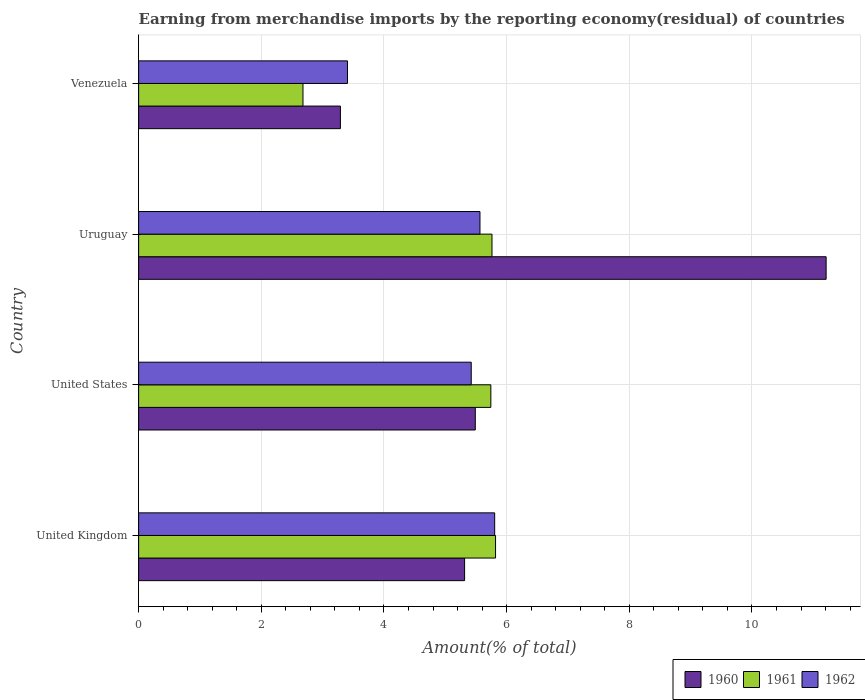How many different coloured bars are there?
Provide a succinct answer. 3. How many groups of bars are there?
Your answer should be compact. 4. Are the number of bars per tick equal to the number of legend labels?
Your response must be concise. Yes. How many bars are there on the 3rd tick from the bottom?
Provide a succinct answer. 3. What is the label of the 3rd group of bars from the top?
Provide a succinct answer. United States. What is the percentage of amount earned from merchandise imports in 1960 in Uruguay?
Make the answer very short. 11.21. Across all countries, what is the maximum percentage of amount earned from merchandise imports in 1962?
Give a very brief answer. 5.8. Across all countries, what is the minimum percentage of amount earned from merchandise imports in 1960?
Your answer should be compact. 3.29. In which country was the percentage of amount earned from merchandise imports in 1960 minimum?
Your answer should be compact. Venezuela. What is the total percentage of amount earned from merchandise imports in 1962 in the graph?
Your response must be concise. 20.2. What is the difference between the percentage of amount earned from merchandise imports in 1962 in United States and that in Uruguay?
Make the answer very short. -0.14. What is the difference between the percentage of amount earned from merchandise imports in 1961 in Venezuela and the percentage of amount earned from merchandise imports in 1960 in Uruguay?
Your answer should be very brief. -8.53. What is the average percentage of amount earned from merchandise imports in 1960 per country?
Make the answer very short. 6.33. What is the difference between the percentage of amount earned from merchandise imports in 1960 and percentage of amount earned from merchandise imports in 1961 in Uruguay?
Ensure brevity in your answer.  5.45. What is the ratio of the percentage of amount earned from merchandise imports in 1960 in United States to that in Venezuela?
Your response must be concise. 1.67. Is the difference between the percentage of amount earned from merchandise imports in 1960 in Uruguay and Venezuela greater than the difference between the percentage of amount earned from merchandise imports in 1961 in Uruguay and Venezuela?
Ensure brevity in your answer.  Yes. What is the difference between the highest and the second highest percentage of amount earned from merchandise imports in 1962?
Your answer should be very brief. 0.24. What is the difference between the highest and the lowest percentage of amount earned from merchandise imports in 1961?
Your answer should be very brief. 3.14. Is the sum of the percentage of amount earned from merchandise imports in 1960 in United States and Uruguay greater than the maximum percentage of amount earned from merchandise imports in 1962 across all countries?
Offer a terse response. Yes. What does the 3rd bar from the top in Uruguay represents?
Provide a succinct answer. 1960. What does the 1st bar from the bottom in United Kingdom represents?
Your answer should be compact. 1960. Is it the case that in every country, the sum of the percentage of amount earned from merchandise imports in 1961 and percentage of amount earned from merchandise imports in 1962 is greater than the percentage of amount earned from merchandise imports in 1960?
Offer a terse response. Yes. How many bars are there?
Keep it short and to the point. 12. Are all the bars in the graph horizontal?
Your answer should be compact. Yes. How many countries are there in the graph?
Make the answer very short. 4. What is the difference between two consecutive major ticks on the X-axis?
Your answer should be compact. 2. Are the values on the major ticks of X-axis written in scientific E-notation?
Your answer should be compact. No. What is the title of the graph?
Ensure brevity in your answer.  Earning from merchandise imports by the reporting economy(residual) of countries. Does "1986" appear as one of the legend labels in the graph?
Your answer should be very brief. No. What is the label or title of the X-axis?
Offer a terse response. Amount(% of total). What is the Amount(% of total) of 1960 in United Kingdom?
Make the answer very short. 5.31. What is the Amount(% of total) in 1961 in United Kingdom?
Provide a short and direct response. 5.82. What is the Amount(% of total) in 1962 in United Kingdom?
Your answer should be compact. 5.8. What is the Amount(% of total) in 1960 in United States?
Your answer should be compact. 5.49. What is the Amount(% of total) in 1961 in United States?
Ensure brevity in your answer.  5.74. What is the Amount(% of total) in 1962 in United States?
Your answer should be compact. 5.42. What is the Amount(% of total) of 1960 in Uruguay?
Give a very brief answer. 11.21. What is the Amount(% of total) of 1961 in Uruguay?
Ensure brevity in your answer.  5.76. What is the Amount(% of total) of 1962 in Uruguay?
Your answer should be very brief. 5.57. What is the Amount(% of total) of 1960 in Venezuela?
Your answer should be compact. 3.29. What is the Amount(% of total) in 1961 in Venezuela?
Make the answer very short. 2.68. What is the Amount(% of total) of 1962 in Venezuela?
Provide a short and direct response. 3.41. Across all countries, what is the maximum Amount(% of total) of 1960?
Provide a succinct answer. 11.21. Across all countries, what is the maximum Amount(% of total) in 1961?
Make the answer very short. 5.82. Across all countries, what is the maximum Amount(% of total) in 1962?
Your answer should be very brief. 5.8. Across all countries, what is the minimum Amount(% of total) in 1960?
Offer a terse response. 3.29. Across all countries, what is the minimum Amount(% of total) in 1961?
Ensure brevity in your answer.  2.68. Across all countries, what is the minimum Amount(% of total) in 1962?
Your answer should be very brief. 3.41. What is the total Amount(% of total) in 1960 in the graph?
Provide a succinct answer. 25.3. What is the total Amount(% of total) of 1961 in the graph?
Give a very brief answer. 20. What is the total Amount(% of total) in 1962 in the graph?
Offer a terse response. 20.2. What is the difference between the Amount(% of total) of 1960 in United Kingdom and that in United States?
Provide a succinct answer. -0.17. What is the difference between the Amount(% of total) in 1961 in United Kingdom and that in United States?
Your answer should be compact. 0.08. What is the difference between the Amount(% of total) of 1962 in United Kingdom and that in United States?
Ensure brevity in your answer.  0.38. What is the difference between the Amount(% of total) of 1960 in United Kingdom and that in Uruguay?
Ensure brevity in your answer.  -5.89. What is the difference between the Amount(% of total) of 1961 in United Kingdom and that in Uruguay?
Provide a succinct answer. 0.06. What is the difference between the Amount(% of total) in 1962 in United Kingdom and that in Uruguay?
Ensure brevity in your answer.  0.24. What is the difference between the Amount(% of total) of 1960 in United Kingdom and that in Venezuela?
Make the answer very short. 2.02. What is the difference between the Amount(% of total) in 1961 in United Kingdom and that in Venezuela?
Your answer should be very brief. 3.14. What is the difference between the Amount(% of total) of 1962 in United Kingdom and that in Venezuela?
Provide a succinct answer. 2.4. What is the difference between the Amount(% of total) of 1960 in United States and that in Uruguay?
Provide a succinct answer. -5.72. What is the difference between the Amount(% of total) in 1961 in United States and that in Uruguay?
Provide a succinct answer. -0.02. What is the difference between the Amount(% of total) of 1962 in United States and that in Uruguay?
Your response must be concise. -0.14. What is the difference between the Amount(% of total) in 1960 in United States and that in Venezuela?
Your response must be concise. 2.2. What is the difference between the Amount(% of total) in 1961 in United States and that in Venezuela?
Ensure brevity in your answer.  3.06. What is the difference between the Amount(% of total) of 1962 in United States and that in Venezuela?
Keep it short and to the point. 2.02. What is the difference between the Amount(% of total) of 1960 in Uruguay and that in Venezuela?
Offer a terse response. 7.92. What is the difference between the Amount(% of total) of 1961 in Uruguay and that in Venezuela?
Make the answer very short. 3.08. What is the difference between the Amount(% of total) of 1962 in Uruguay and that in Venezuela?
Your answer should be very brief. 2.16. What is the difference between the Amount(% of total) in 1960 in United Kingdom and the Amount(% of total) in 1961 in United States?
Make the answer very short. -0.43. What is the difference between the Amount(% of total) of 1960 in United Kingdom and the Amount(% of total) of 1962 in United States?
Your response must be concise. -0.11. What is the difference between the Amount(% of total) of 1961 in United Kingdom and the Amount(% of total) of 1962 in United States?
Ensure brevity in your answer.  0.4. What is the difference between the Amount(% of total) in 1960 in United Kingdom and the Amount(% of total) in 1961 in Uruguay?
Give a very brief answer. -0.45. What is the difference between the Amount(% of total) of 1960 in United Kingdom and the Amount(% of total) of 1962 in Uruguay?
Keep it short and to the point. -0.25. What is the difference between the Amount(% of total) of 1961 in United Kingdom and the Amount(% of total) of 1962 in Uruguay?
Give a very brief answer. 0.25. What is the difference between the Amount(% of total) of 1960 in United Kingdom and the Amount(% of total) of 1961 in Venezuela?
Offer a very short reply. 2.63. What is the difference between the Amount(% of total) in 1960 in United Kingdom and the Amount(% of total) in 1962 in Venezuela?
Make the answer very short. 1.91. What is the difference between the Amount(% of total) of 1961 in United Kingdom and the Amount(% of total) of 1962 in Venezuela?
Make the answer very short. 2.41. What is the difference between the Amount(% of total) in 1960 in United States and the Amount(% of total) in 1961 in Uruguay?
Your response must be concise. -0.27. What is the difference between the Amount(% of total) of 1960 in United States and the Amount(% of total) of 1962 in Uruguay?
Ensure brevity in your answer.  -0.08. What is the difference between the Amount(% of total) in 1961 in United States and the Amount(% of total) in 1962 in Uruguay?
Your answer should be very brief. 0.18. What is the difference between the Amount(% of total) in 1960 in United States and the Amount(% of total) in 1961 in Venezuela?
Ensure brevity in your answer.  2.81. What is the difference between the Amount(% of total) of 1960 in United States and the Amount(% of total) of 1962 in Venezuela?
Offer a terse response. 2.08. What is the difference between the Amount(% of total) of 1961 in United States and the Amount(% of total) of 1962 in Venezuela?
Your answer should be compact. 2.34. What is the difference between the Amount(% of total) of 1960 in Uruguay and the Amount(% of total) of 1961 in Venezuela?
Offer a terse response. 8.53. What is the difference between the Amount(% of total) in 1960 in Uruguay and the Amount(% of total) in 1962 in Venezuela?
Offer a very short reply. 7.8. What is the difference between the Amount(% of total) in 1961 in Uruguay and the Amount(% of total) in 1962 in Venezuela?
Your answer should be compact. 2.36. What is the average Amount(% of total) in 1960 per country?
Offer a terse response. 6.33. What is the average Amount(% of total) of 1961 per country?
Your answer should be compact. 5. What is the average Amount(% of total) of 1962 per country?
Offer a terse response. 5.05. What is the difference between the Amount(% of total) in 1960 and Amount(% of total) in 1961 in United Kingdom?
Offer a terse response. -0.5. What is the difference between the Amount(% of total) of 1960 and Amount(% of total) of 1962 in United Kingdom?
Your answer should be very brief. -0.49. What is the difference between the Amount(% of total) in 1961 and Amount(% of total) in 1962 in United Kingdom?
Make the answer very short. 0.01. What is the difference between the Amount(% of total) in 1960 and Amount(% of total) in 1961 in United States?
Make the answer very short. -0.25. What is the difference between the Amount(% of total) of 1960 and Amount(% of total) of 1962 in United States?
Your response must be concise. 0.07. What is the difference between the Amount(% of total) of 1961 and Amount(% of total) of 1962 in United States?
Give a very brief answer. 0.32. What is the difference between the Amount(% of total) of 1960 and Amount(% of total) of 1961 in Uruguay?
Offer a terse response. 5.45. What is the difference between the Amount(% of total) of 1960 and Amount(% of total) of 1962 in Uruguay?
Your answer should be compact. 5.64. What is the difference between the Amount(% of total) of 1961 and Amount(% of total) of 1962 in Uruguay?
Offer a very short reply. 0.2. What is the difference between the Amount(% of total) in 1960 and Amount(% of total) in 1961 in Venezuela?
Offer a terse response. 0.61. What is the difference between the Amount(% of total) of 1960 and Amount(% of total) of 1962 in Venezuela?
Make the answer very short. -0.12. What is the difference between the Amount(% of total) of 1961 and Amount(% of total) of 1962 in Venezuela?
Make the answer very short. -0.73. What is the ratio of the Amount(% of total) of 1960 in United Kingdom to that in United States?
Make the answer very short. 0.97. What is the ratio of the Amount(% of total) in 1961 in United Kingdom to that in United States?
Make the answer very short. 1.01. What is the ratio of the Amount(% of total) of 1962 in United Kingdom to that in United States?
Provide a short and direct response. 1.07. What is the ratio of the Amount(% of total) of 1960 in United Kingdom to that in Uruguay?
Offer a very short reply. 0.47. What is the ratio of the Amount(% of total) of 1961 in United Kingdom to that in Uruguay?
Make the answer very short. 1.01. What is the ratio of the Amount(% of total) in 1962 in United Kingdom to that in Uruguay?
Provide a short and direct response. 1.04. What is the ratio of the Amount(% of total) of 1960 in United Kingdom to that in Venezuela?
Ensure brevity in your answer.  1.62. What is the ratio of the Amount(% of total) in 1961 in United Kingdom to that in Venezuela?
Make the answer very short. 2.17. What is the ratio of the Amount(% of total) of 1962 in United Kingdom to that in Venezuela?
Keep it short and to the point. 1.7. What is the ratio of the Amount(% of total) of 1960 in United States to that in Uruguay?
Your response must be concise. 0.49. What is the ratio of the Amount(% of total) of 1961 in United States to that in Uruguay?
Offer a terse response. 1. What is the ratio of the Amount(% of total) of 1962 in United States to that in Uruguay?
Your response must be concise. 0.97. What is the ratio of the Amount(% of total) of 1960 in United States to that in Venezuela?
Ensure brevity in your answer.  1.67. What is the ratio of the Amount(% of total) of 1961 in United States to that in Venezuela?
Provide a short and direct response. 2.14. What is the ratio of the Amount(% of total) in 1962 in United States to that in Venezuela?
Your answer should be very brief. 1.59. What is the ratio of the Amount(% of total) of 1960 in Uruguay to that in Venezuela?
Offer a very short reply. 3.41. What is the ratio of the Amount(% of total) of 1961 in Uruguay to that in Venezuela?
Your response must be concise. 2.15. What is the ratio of the Amount(% of total) of 1962 in Uruguay to that in Venezuela?
Keep it short and to the point. 1.63. What is the difference between the highest and the second highest Amount(% of total) in 1960?
Keep it short and to the point. 5.72. What is the difference between the highest and the second highest Amount(% of total) in 1961?
Keep it short and to the point. 0.06. What is the difference between the highest and the second highest Amount(% of total) in 1962?
Offer a very short reply. 0.24. What is the difference between the highest and the lowest Amount(% of total) of 1960?
Keep it short and to the point. 7.92. What is the difference between the highest and the lowest Amount(% of total) of 1961?
Provide a short and direct response. 3.14. What is the difference between the highest and the lowest Amount(% of total) of 1962?
Your response must be concise. 2.4. 